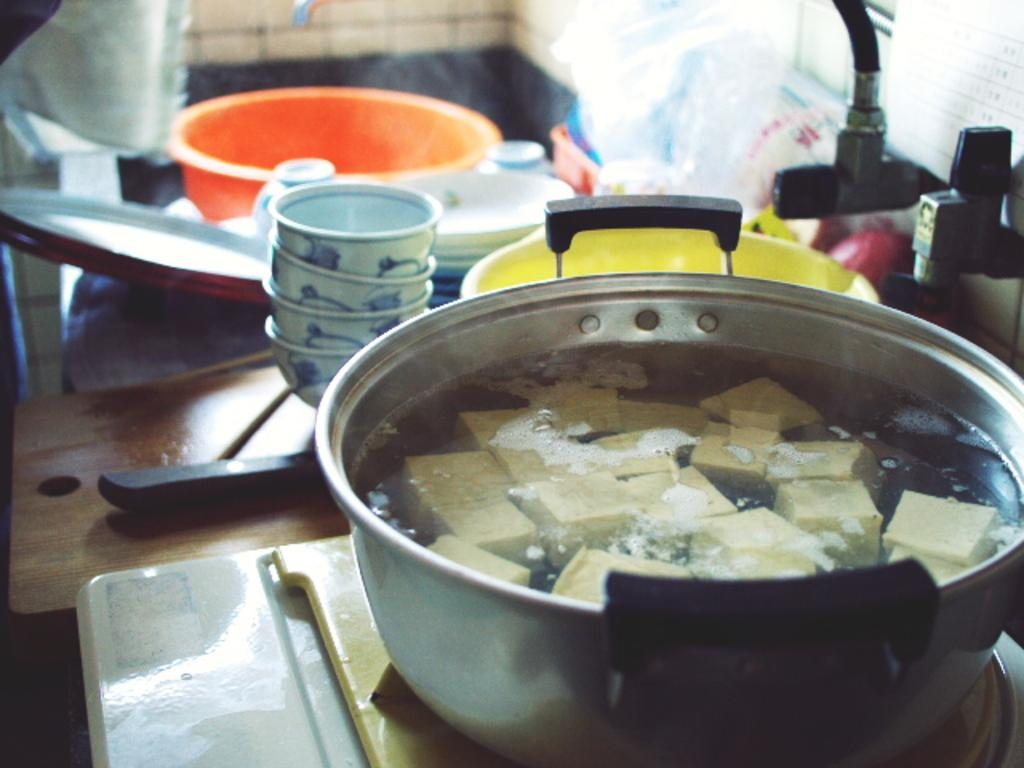What is being cooked in the cooking vessel in the image? The specific food item is not mentioned, but there is a food item in a cooking vessel in the image. Where is the cooking vessel located? The cooking vessel is on a stove in the image. What type of dishware can be seen in the image? There are bowls and plates visible in the image. What surface might be used for cutting or preparing food in the image? There is a chopping board visible in the image. Can you describe any other objects present in the image? There are other objects present in the image, but their specific details are not mentioned. Is there a ray visible in the image? No, there is no ray present in the image. Can you tell me how many combs are on the chopping board? There are no combs present in the image. 